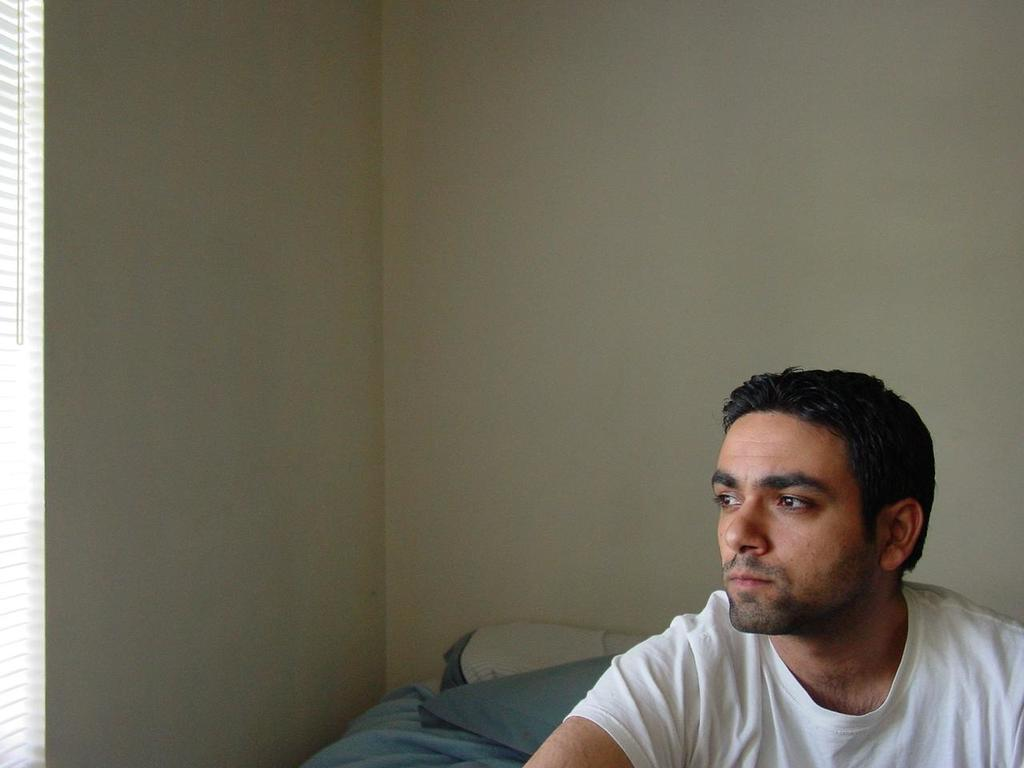Who or what is on the right side of the image? There is a person on the right side of the image. What can be seen in the background of the image? There is a wall in the background of the image. What type of whistle is the person wearing on their stocking in the image? There is no whistle or stocking present in the image, and therefore no such item can be observed. 